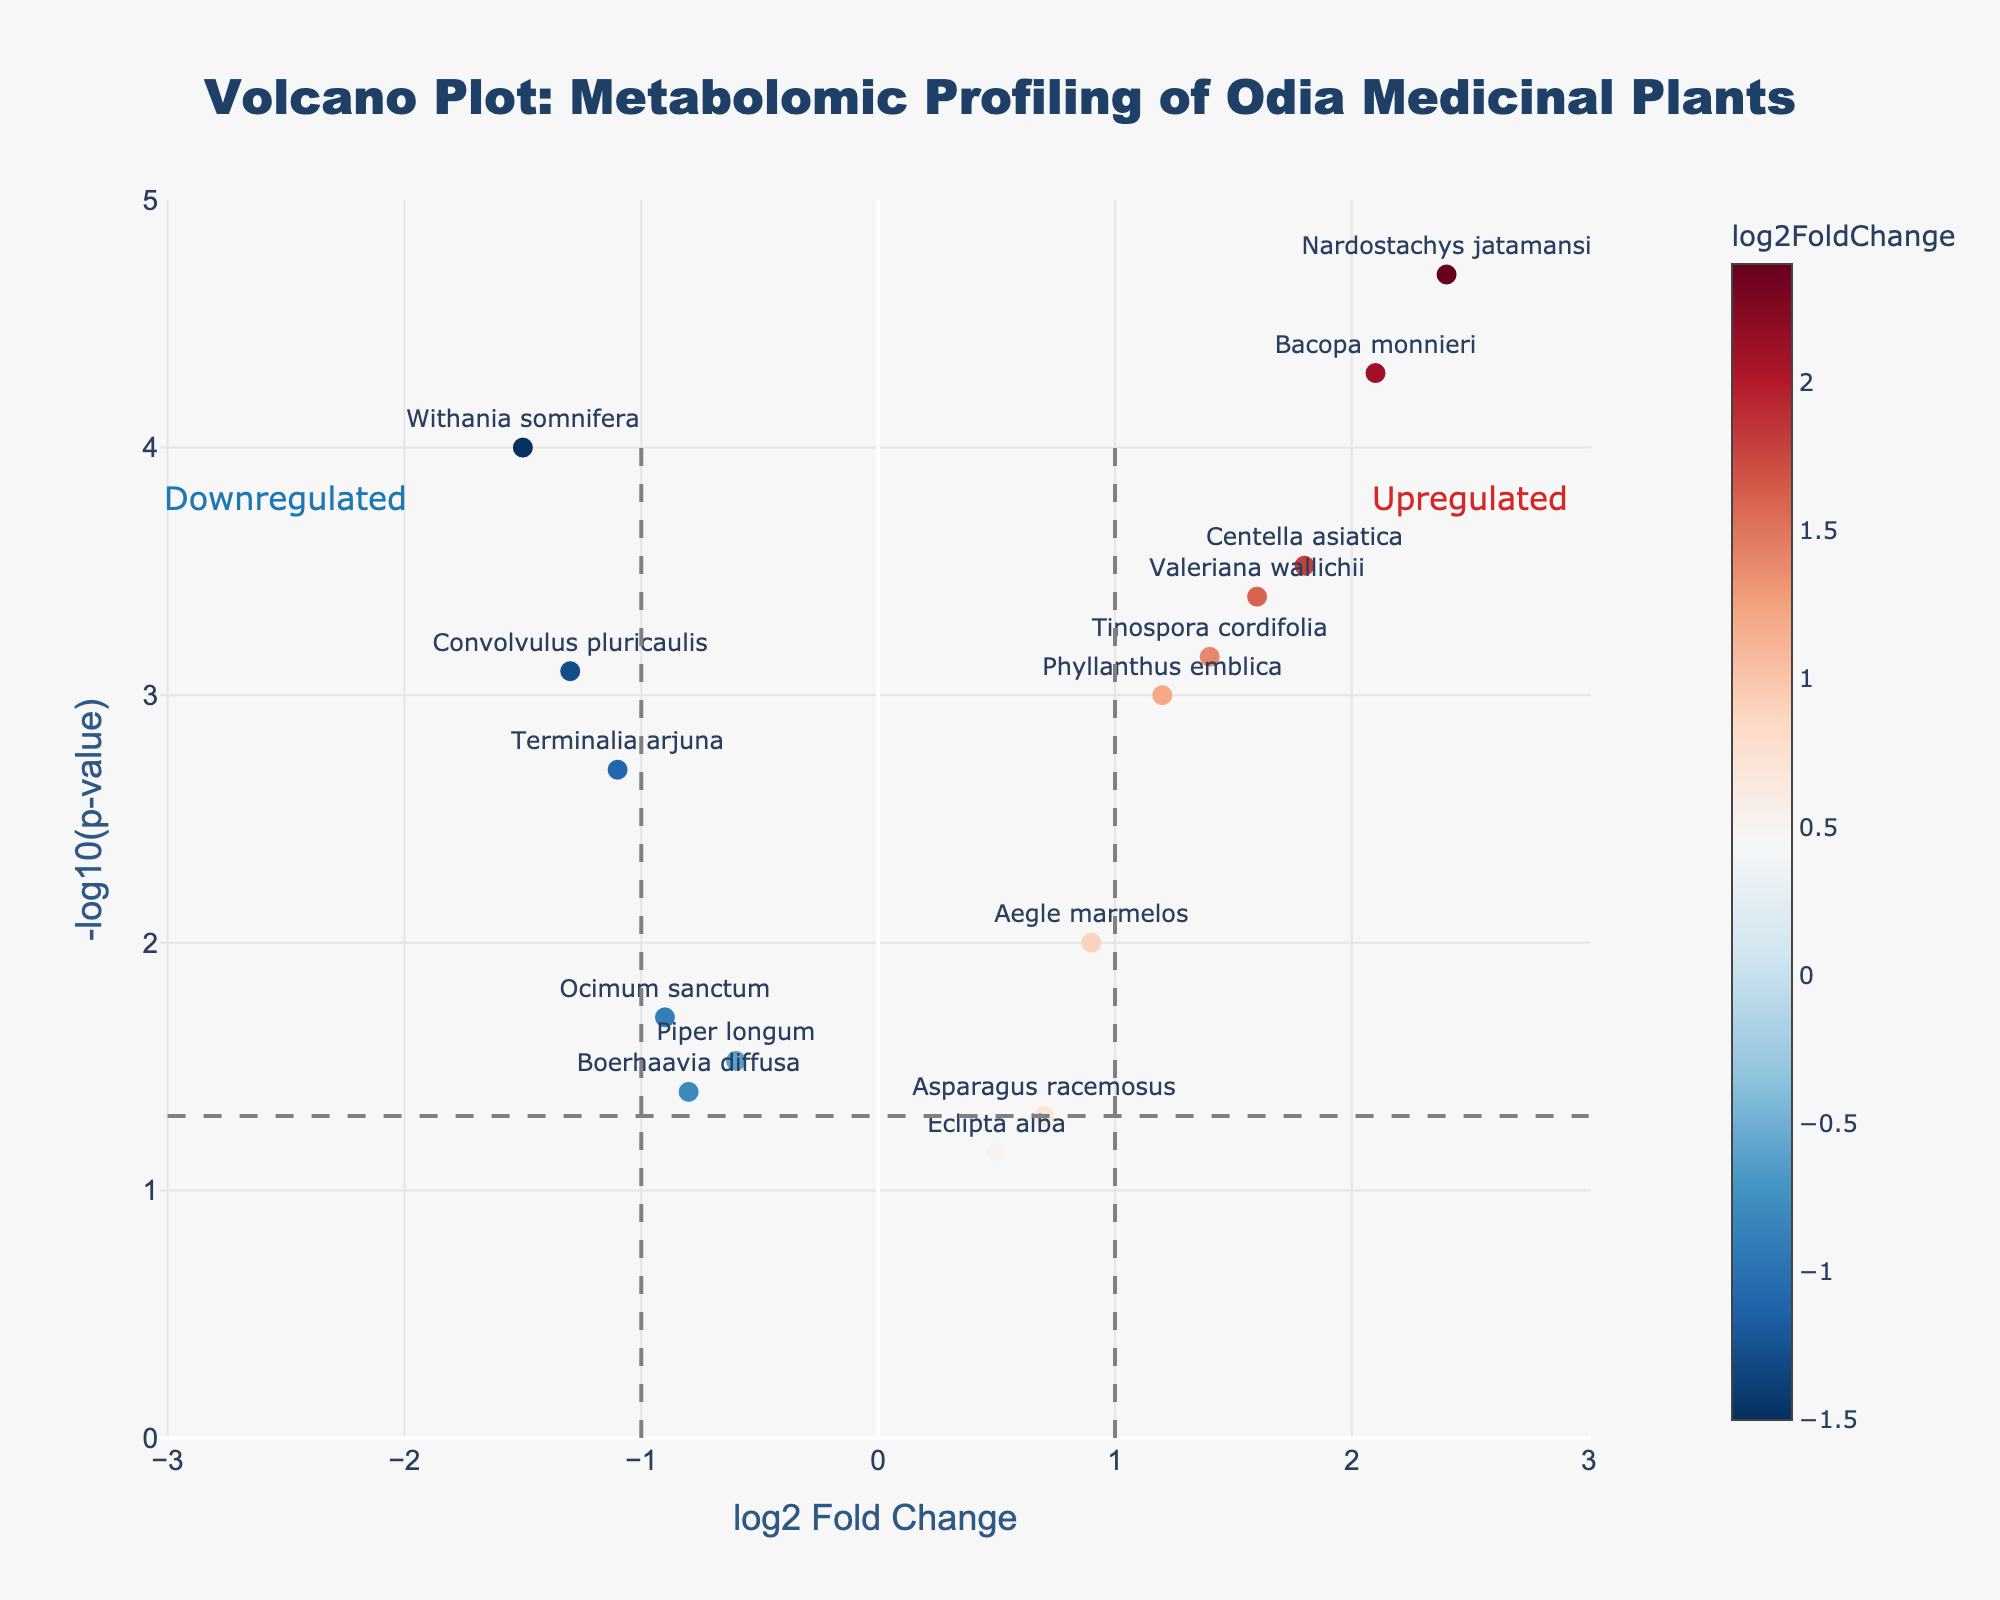Which medicinal plant has the highest -log10(p-value)? The plant with the highest -log10(p-value) will appear highest on the y-axis of the plot. Nardostachys jatamansi is positioned at the top of the plot.
Answer: Nardostachys jatamansi Which medicinal plants are upregulated? Upregulated plants will be on the right side of the vertical line at log2 Fold Change = 1. Bacopa monnieri, Centella asiatica, Phyllanthus emblica, Nardostachys jatamansi, Valeriana wallichii, Tinospora cordifolia, and Aegle marmelos are on the right side.
Answer: Bacopa monnieri, Centella asiatica, Phyllanthus emblica, Nardostachys jatamansi, Valeriana wallichii, Tinospora cordifolia, Aegle marmelos Which medicinal plant has the most significant downregulation, and what is its log2 Fold Change? The plant with the most significant downregulation will have the lowest log2 Fold Change value and be positioned furthest to the left on the x-axis. Withania somnifera is at the leftmost position with a log2 Fold Change of -1.5.
Answer: Withania somnifera, -1.5 How many medicinal plants have a p-value less than 0.001? To find this, look for plants above the horizontal line at -log10(p-value) of approximately 3 (since -log10(0.001) = 3). Bacopa monnieri, Nardostachys jatamansi, Withania somnifera, Centella asiatica, Convolvulus pluricaulis, Valeriana wallichii, and Tinospora cordifolia are above this line.
Answer: 7 Which medicinal plant shows a modest upregulation with a -log10(p-value) just above 1? To find this, look for a point right of the centerline (log2 Fold Change > 1) and close to the horizontal line at -log10(p-value) = 1.3. Aegle marmelos fit this description.
Answer: Aegle marmelos What does a log2 Fold Change value of 0 represent, and how many plants are near this threshold? A log2 Fold Change of 0 means no change. Points close to the center vertical line (log2 Fold Change near 0) are Ocimum sanctum, Boerhaavia diffusa, and Piper longum, but none are exactly at 0.
Answer: 3 